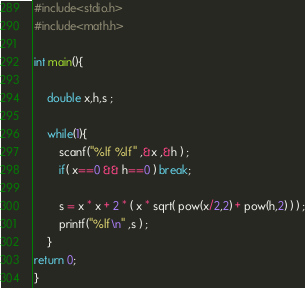<code> <loc_0><loc_0><loc_500><loc_500><_C_>#include<stdio.h>
#include<math.h>

int main(){
	
	double x,h,s ;
	
	while(1){
		scanf("%lf %lf" ,&x ,&h ) ;
		if( x==0 && h==0 ) break;
		
		s = x * x + 2 * ( x * sqrt( pow(x/2,2) + pow(h,2) ) ) ;
		printf("%lf\n" ,s ) ;
	}
return 0;
}</code> 